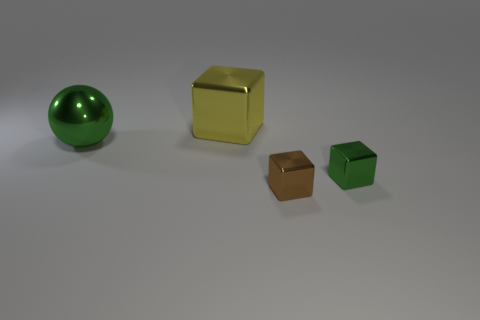Add 3 yellow cubes. How many objects exist? 7 Subtract all balls. How many objects are left? 3 Subtract all big red shiny cylinders. Subtract all tiny green shiny cubes. How many objects are left? 3 Add 2 big yellow things. How many big yellow things are left? 3 Add 2 brown blocks. How many brown blocks exist? 3 Subtract 0 cyan cubes. How many objects are left? 4 